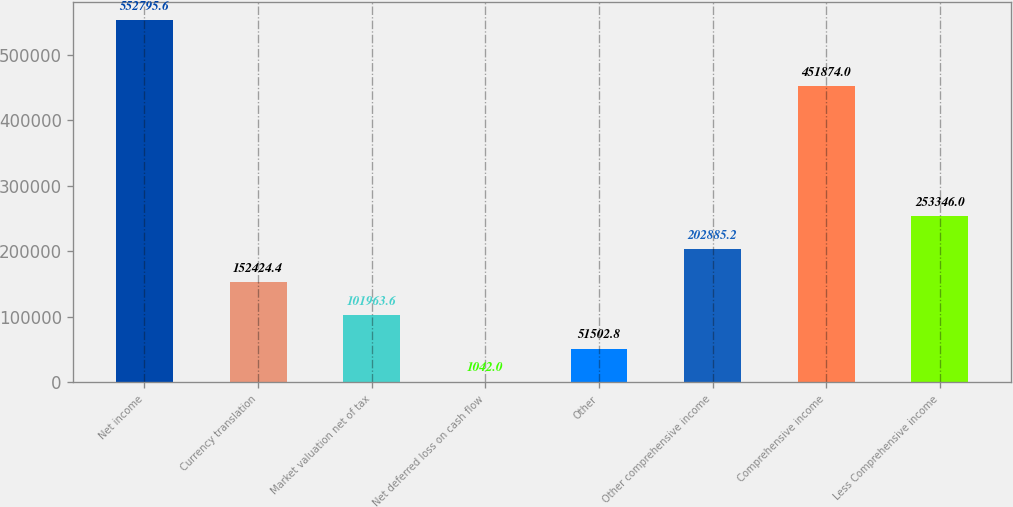Convert chart to OTSL. <chart><loc_0><loc_0><loc_500><loc_500><bar_chart><fcel>Net income<fcel>Currency translation<fcel>Market valuation net of tax<fcel>Net deferred loss on cash flow<fcel>Other<fcel>Other comprehensive income<fcel>Comprehensive income<fcel>Less Comprehensive income<nl><fcel>552796<fcel>152424<fcel>101964<fcel>1042<fcel>51502.8<fcel>202885<fcel>451874<fcel>253346<nl></chart> 